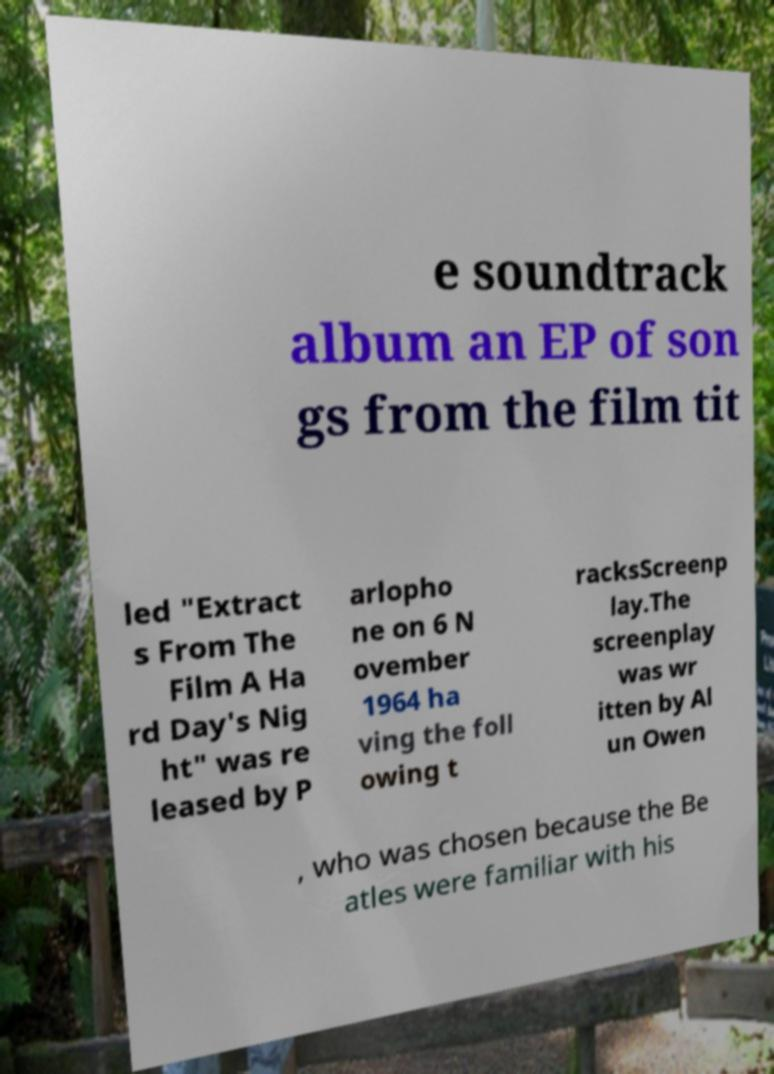Can you read and provide the text displayed in the image?This photo seems to have some interesting text. Can you extract and type it out for me? e soundtrack album an EP of son gs from the film tit led "Extract s From The Film A Ha rd Day's Nig ht" was re leased by P arlopho ne on 6 N ovember 1964 ha ving the foll owing t racksScreenp lay.The screenplay was wr itten by Al un Owen , who was chosen because the Be atles were familiar with his 